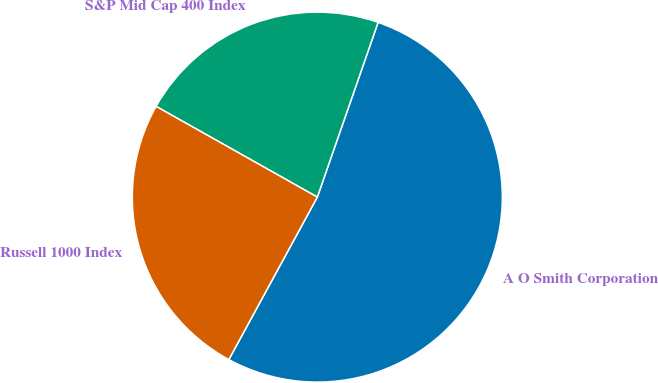Convert chart to OTSL. <chart><loc_0><loc_0><loc_500><loc_500><pie_chart><fcel>A O Smith Corporation<fcel>S&P Mid Cap 400 Index<fcel>Russell 1000 Index<nl><fcel>52.61%<fcel>22.17%<fcel>25.22%<nl></chart> 